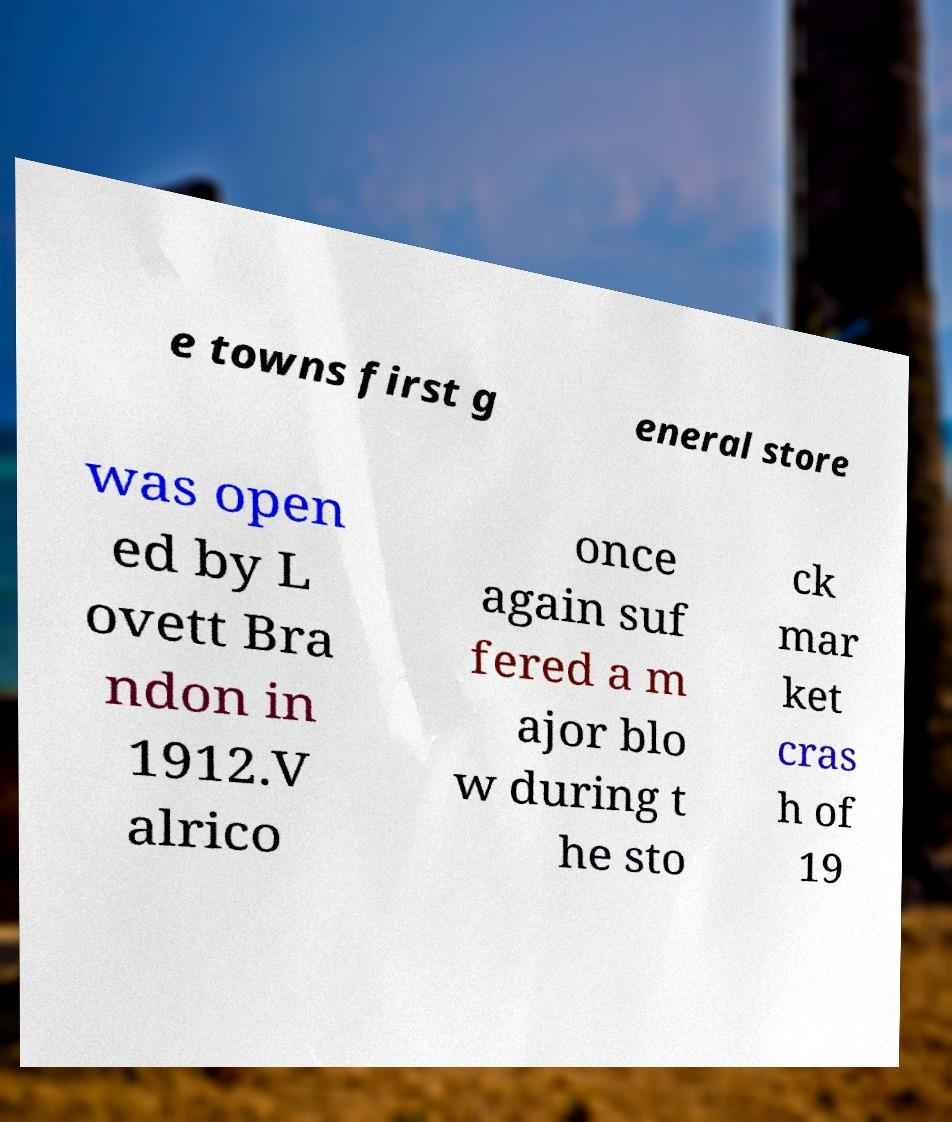For documentation purposes, I need the text within this image transcribed. Could you provide that? e towns first g eneral store was open ed by L ovett Bra ndon in 1912.V alrico once again suf fered a m ajor blo w during t he sto ck mar ket cras h of 19 